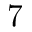Convert formula to latex. <formula><loc_0><loc_0><loc_500><loc_500>7</formula> 